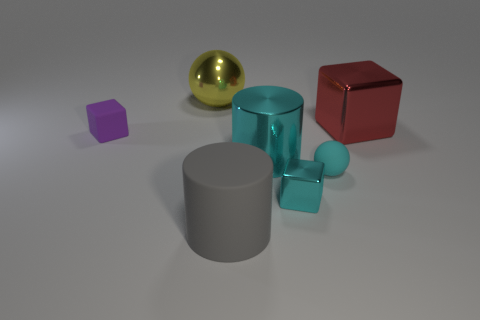Add 3 big metallic cubes. How many objects exist? 10 Subtract all blocks. How many objects are left? 4 Subtract all tiny purple matte objects. Subtract all cyan balls. How many objects are left? 5 Add 1 big gray things. How many big gray things are left? 2 Add 5 large cyan metallic objects. How many large cyan metallic objects exist? 6 Subtract 0 green blocks. How many objects are left? 7 